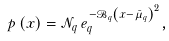Convert formula to latex. <formula><loc_0><loc_0><loc_500><loc_500>p \left ( x \right ) = \mathcal { N } _ { q } \, e _ { q } ^ { - \mathcal { B } _ { q } \left ( x - \bar { \mu } _ { q } \right ) ^ { 2 } } ,</formula> 